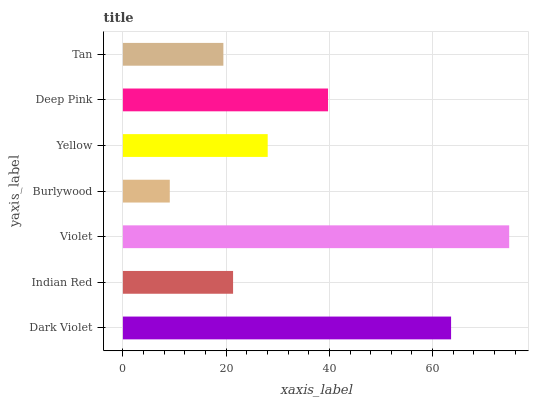Is Burlywood the minimum?
Answer yes or no. Yes. Is Violet the maximum?
Answer yes or no. Yes. Is Indian Red the minimum?
Answer yes or no. No. Is Indian Red the maximum?
Answer yes or no. No. Is Dark Violet greater than Indian Red?
Answer yes or no. Yes. Is Indian Red less than Dark Violet?
Answer yes or no. Yes. Is Indian Red greater than Dark Violet?
Answer yes or no. No. Is Dark Violet less than Indian Red?
Answer yes or no. No. Is Yellow the high median?
Answer yes or no. Yes. Is Yellow the low median?
Answer yes or no. Yes. Is Deep Pink the high median?
Answer yes or no. No. Is Burlywood the low median?
Answer yes or no. No. 